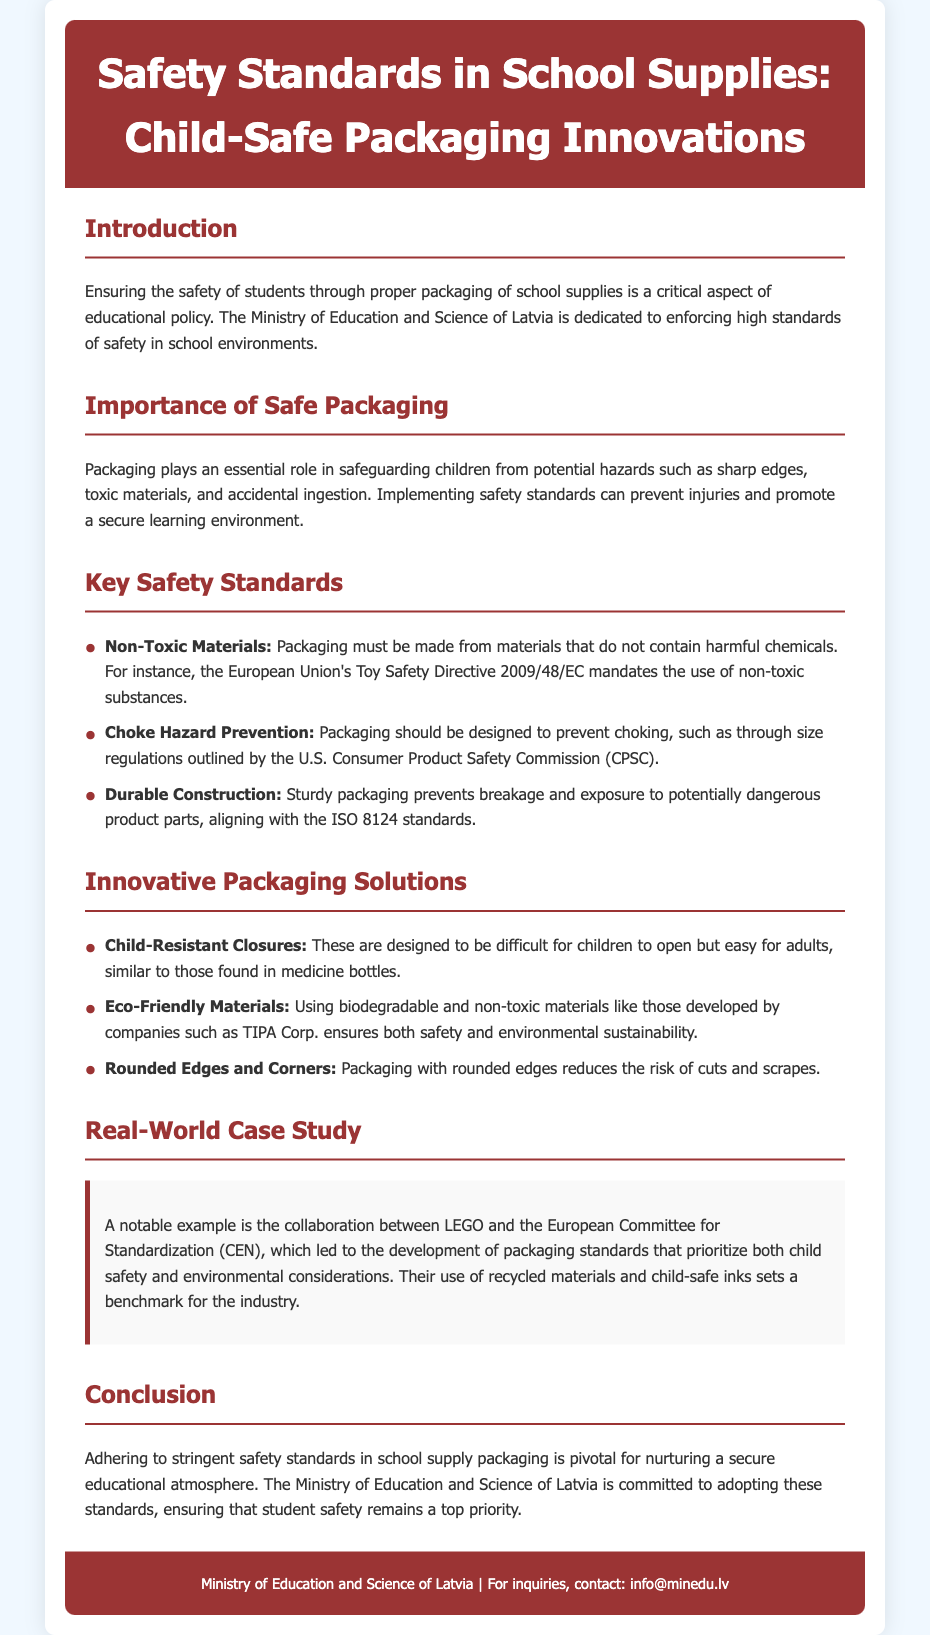What is the title of the document? The title can be found in the header section of the document.
Answer: Safety Standards in School Supplies: Child-Safe Packaging Innovations What is one of the key safety standards mentioned? The document lists several key safety standards for packaging.
Answer: Non-Toxic Materials Which organization’s directive mandates the use of non-toxic substances? The document provides the name of the directive related to safety standards.
Answer: European Union's Toy Safety Directive 2009/48/EC What is an innovative packaging solution mentioned? The document lists various innovative packaging solutions that enhance safety.
Answer: Child-Resistant Closures What is the main focus of the Introduction section? The Introduction outlines the primary concern addressed in the document.
Answer: Safety of students Who collaborated with LEGO for packaging standards? The document mentions a collaboration that led to significant packaging innovations.
Answer: European Committee for Standardization (CEN) What does durable construction in packaging prevent? The document highlights the importance of durability in packaging standards.
Answer: Breakage What is a benefit of rounded edges and corners in packaging? The document explains how design features can enhance safety in packaging.
Answer: Reduces the risk of cuts and scrapes What is the email for inquiries stated in the footer? The footer contains contact information for further questions or inquiries.
Answer: info@minedu.lv 